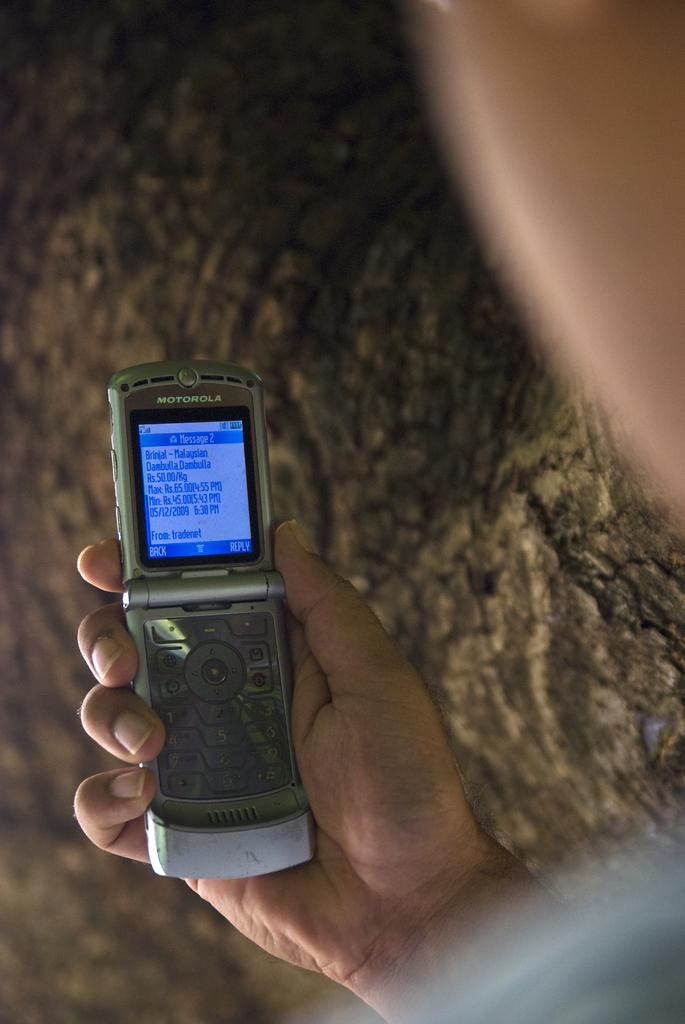Provide a one-sentence caption for the provided image. MOTOROLA FLIP PHONE WITH BLUE ON BLUE TEXT SCREEN. 